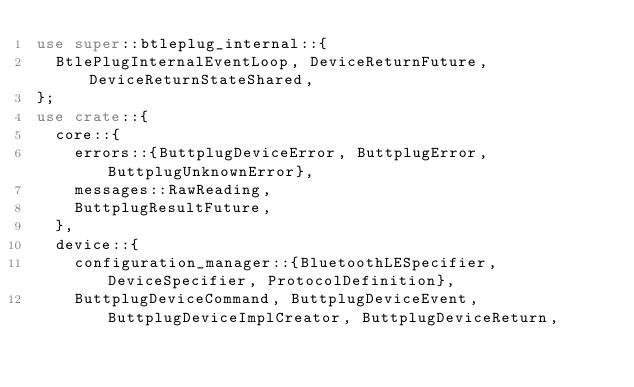Convert code to text. <code><loc_0><loc_0><loc_500><loc_500><_Rust_>use super::btleplug_internal::{
  BtlePlugInternalEventLoop, DeviceReturnFuture, DeviceReturnStateShared,
};
use crate::{
  core::{
    errors::{ButtplugDeviceError, ButtplugError, ButtplugUnknownError},
    messages::RawReading,
    ButtplugResultFuture,
  },
  device::{
    configuration_manager::{BluetoothLESpecifier, DeviceSpecifier, ProtocolDefinition},
    ButtplugDeviceCommand, ButtplugDeviceEvent, ButtplugDeviceImplCreator, ButtplugDeviceReturn,</code> 